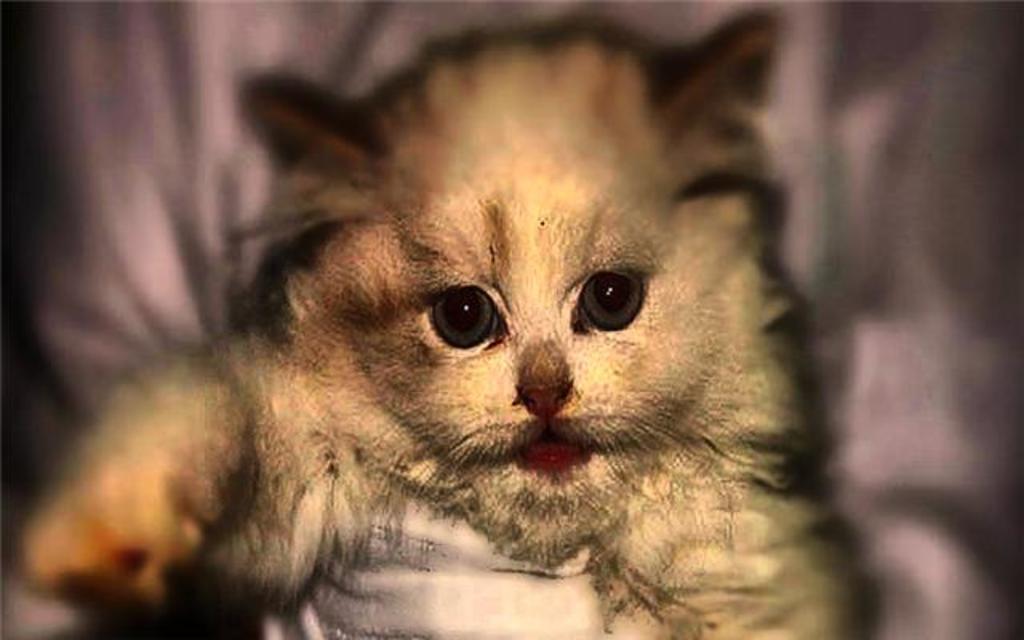Can you describe this image briefly? This image is an edited image. In the middle there is an animal. 